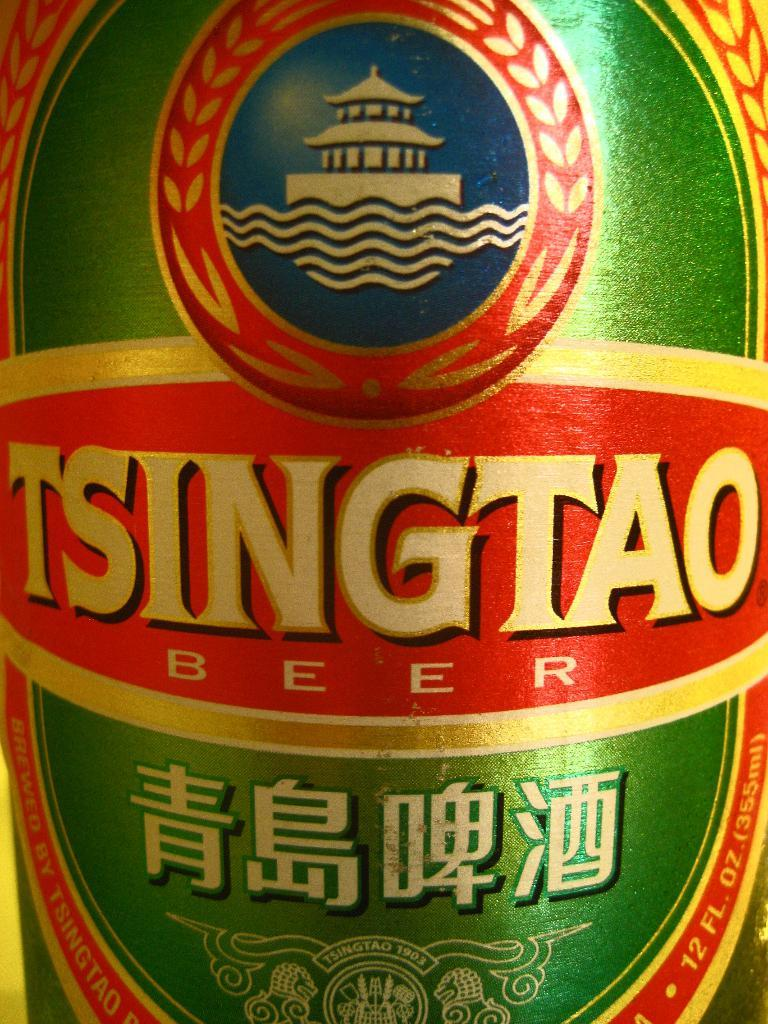What object can be seen in the image? There is a bottle in the image. Can you describe the sticker on the bottle? The sticker on the bottle has green, red, and gold colors. What type of jelly is being used by the fireman in the image? There is no fireman or jelly present in the image; it only features a bottle with a sticker. 